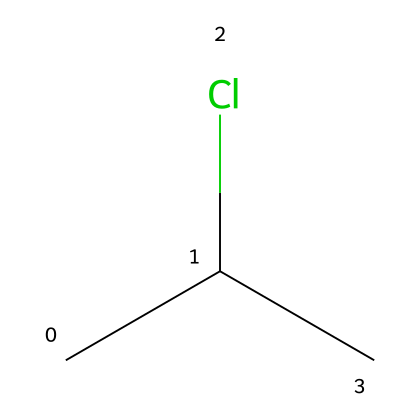What is the main element present in this chemical? The chemical structure shows a carbon atom (C) and a chlorine atom (Cl), which indicates that the primary element is carbon.
Answer: carbon How many chlorine atoms are present in this chemical? Observing the SMILES representation CC(Cl)C, there is one chlorine atom (Cl) attached to one of the carbon atoms in the structure.
Answer: one What type of plastic is indicated by this chemical composition? The presence of vinyl groups (CC) and chlorine indicates that this chemical is polyvinyl chloride (PVC), a common plastic used in medical applications.
Answer: polyvinyl chloride What type of bond connects the carbon atoms in this structure? The SMILES representation indicates single bonds between the carbon atoms (C-C), which is characteristic of aliphatic hydrocarbons.
Answer: single bond How does the presence of chlorine affect the properties of the plastic? The chlorine substituent increases the polarity of the polymer, enhancing chemical resistance and making it suitable for medical products such as blood bags and tubing.
Answer: increases polarity What two functional groups can be identified in this chemical? In the structure represented by CC(Cl)C, the two functional groups present are the alkane chain (represented by the carbon atoms) and the chlorine substituent (Cl).
Answer: alkane and chlorine How many total atoms are in this chemical structure? Counting all the atoms in the SMILES representation, there are three carbon atoms and one chlorine atom, leading to a total of four atoms in the structure.
Answer: four 